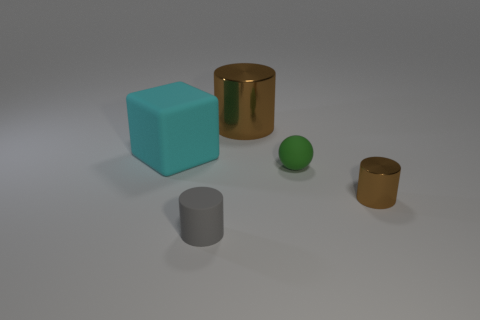Subtract 1 cylinders. How many cylinders are left? 2 Subtract all large brown cylinders. How many cylinders are left? 2 Add 4 big gray rubber cubes. How many objects exist? 9 Subtract all spheres. How many objects are left? 4 Add 5 cyan things. How many cyan things exist? 6 Subtract 0 red cylinders. How many objects are left? 5 Subtract all small yellow rubber things. Subtract all blocks. How many objects are left? 4 Add 3 large cyan matte cubes. How many large cyan matte cubes are left? 4 